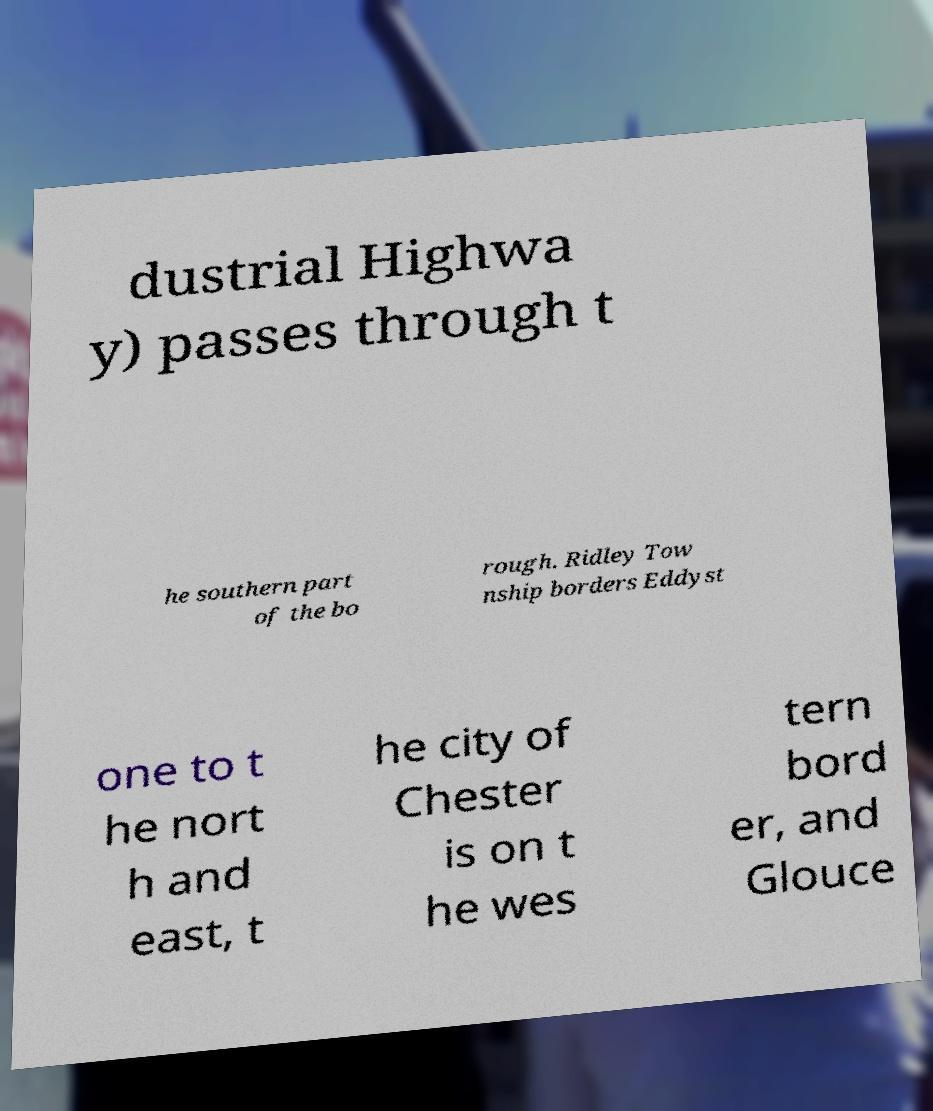Please identify and transcribe the text found in this image. dustrial Highwa y) passes through t he southern part of the bo rough. Ridley Tow nship borders Eddyst one to t he nort h and east, t he city of Chester is on t he wes tern bord er, and Glouce 